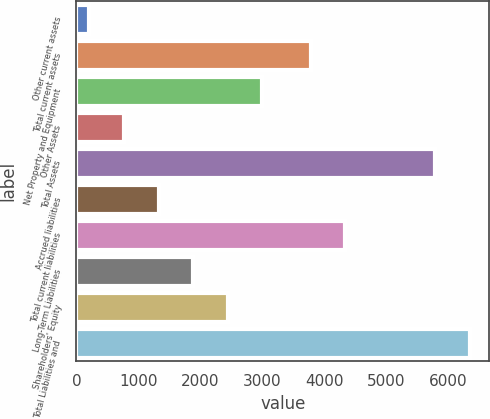Convert chart to OTSL. <chart><loc_0><loc_0><loc_500><loc_500><bar_chart><fcel>Other current assets<fcel>Total current assets<fcel>Net Property and Equipment<fcel>Other Assets<fcel>Total Assets<fcel>Accrued liabilities<fcel>Total current liabilities<fcel>Long-Term Liabilities<fcel>Shareholders' Equity<fcel>Total Liabilities and<nl><fcel>211<fcel>3782<fcel>2999<fcel>768.6<fcel>5787<fcel>1326.2<fcel>4339.6<fcel>1883.8<fcel>2441.4<fcel>6344.6<nl></chart> 